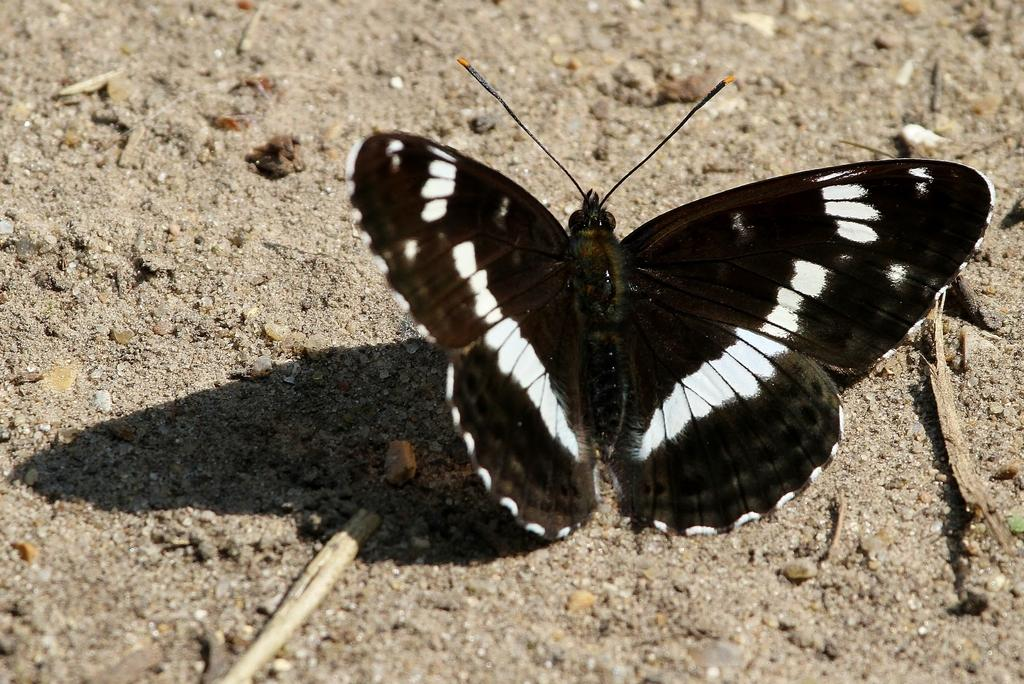What is the main subject of the image? The main subject of the image is a butterfly. Can you describe the location of the butterfly in the image? The butterfly is on the ground in the image. How many earths can be seen in the image? There are no earths present in the image; it features a butterfly on the ground. How many legs does the butterfly's aunt have in the image? There is no reference to a butterfly's aunt or any legs in the image. 